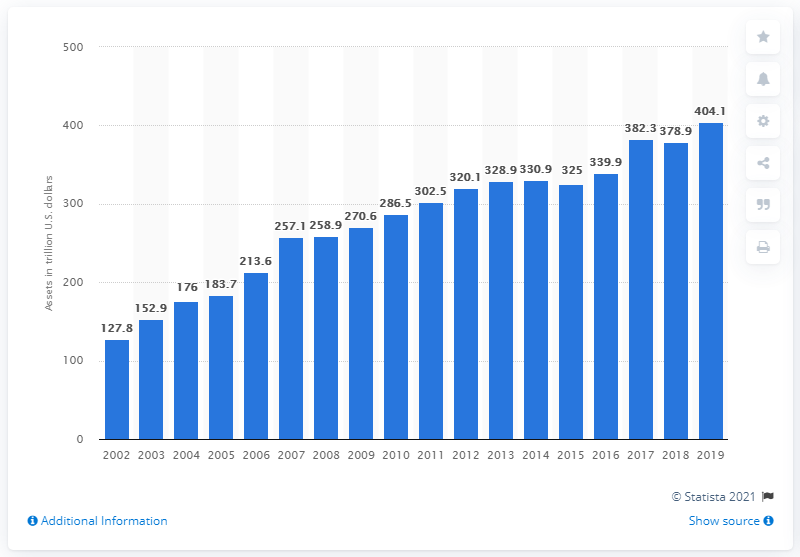Indicate a few pertinent items in this graphic. The value of assets of global financial institutions increased in 2002. In 2019, the assets of financial institutions worldwide were valued at approximately 404.1 billion U.S. dollars. 